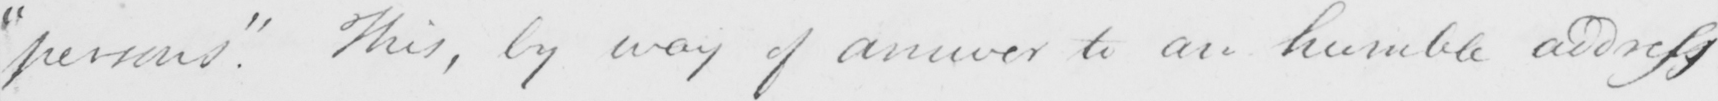Can you tell me what this handwritten text says? " persons "  . This , by way of answer to an humble address 